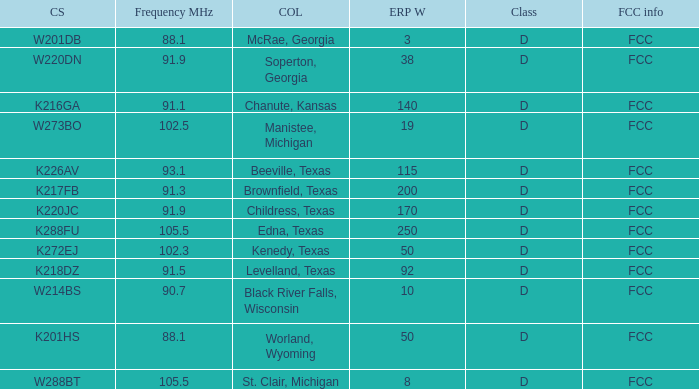What is the Sum of ERP W, when Call Sign is K216GA? 140.0. 